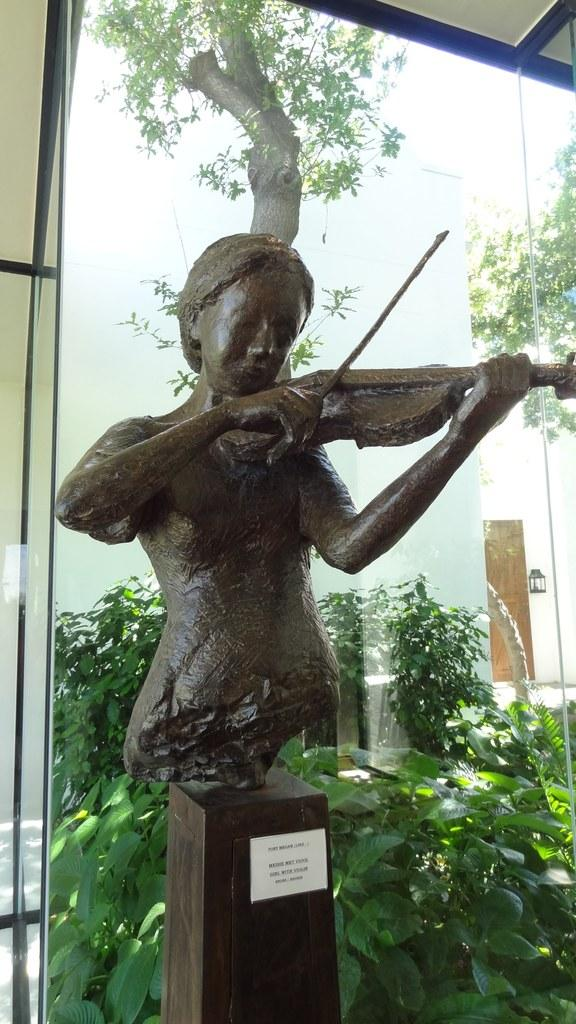What activity is being depicted in the image? There is a depiction of a person playing the violin in the image. What can be seen in the background of the image? There are trees in the background of the image. What type of toothbrush is the person using while playing the violin in the image? There is no toothbrush present in the image, as the person is playing the violin. 